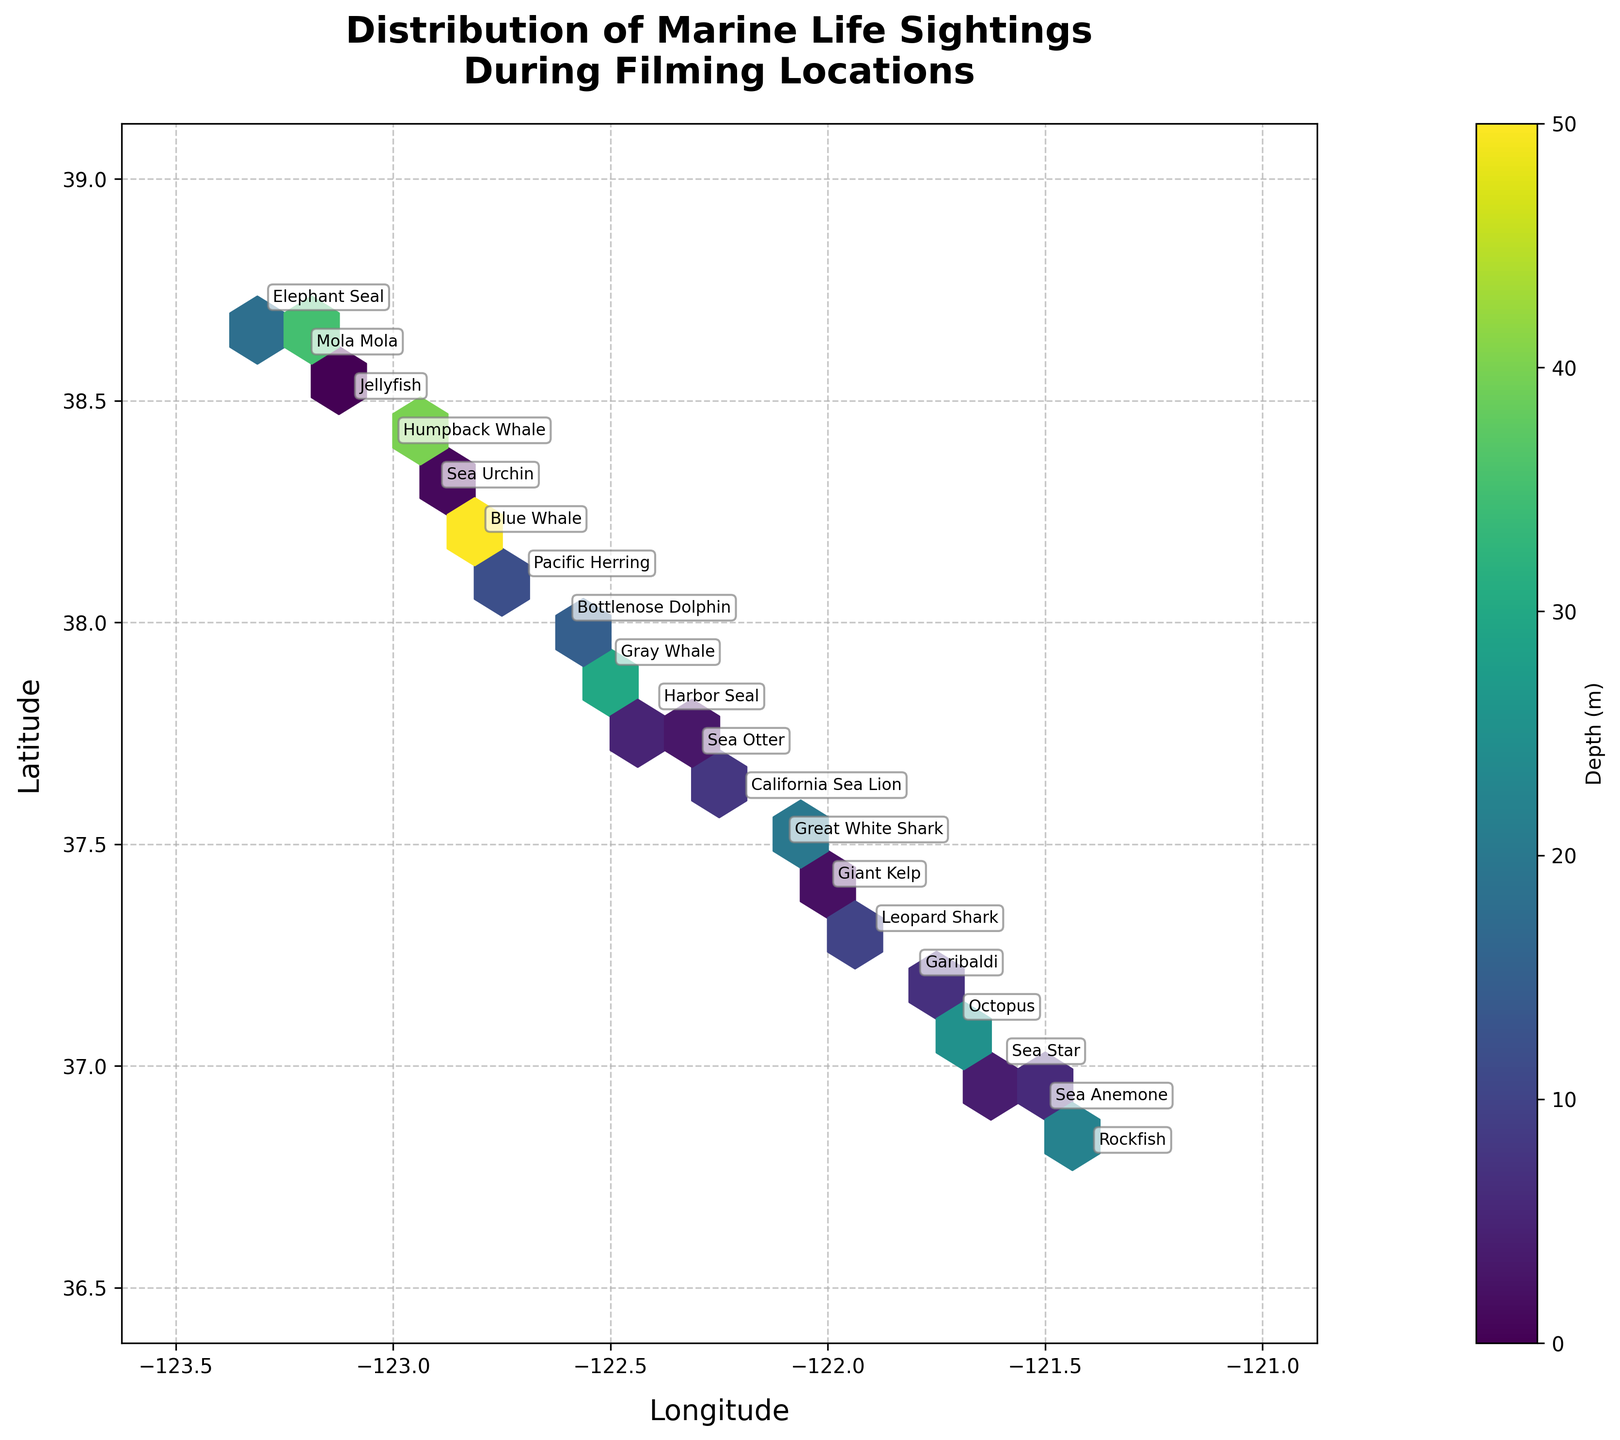What's the title of the plot? The title is displayed at the top of the plot, prominently explaining the plot's purpose. The title here is "Distribution of Marine Life Sightings During Filming Locations".
Answer: Distribution of Marine Life Sightings During Filming Locations What do the colors in the plot represent? The color bar on the right side of the plot indicates that colors represent depth in meters. Darker colors correspond to shallower depths, while lighter colors represent deeper depths.
Answer: Depth (m) What are the axes labeled? The labels for the axes are found next to each respective axis. The x-axis is labeled "Longitude" and the y-axis is labeled "Latitude".
Answer: Longitude and Latitude Which species is located at the shallowest depth? By looking at the annotations overlaid on the plot with the corresponding depths, we see that Jellyfish is marked at depth '0', which is the shallowest.
Answer: Jellyfish How does the density of sightings change from longitude -123.3 to -121.8? By observing the color density in the hexbin plot from longitude -123.3 to -121.8, we can see the density and depth of sightings reduce moving from west to east. There are more sightings near -123.3, as indicated by a higher frequency of hexagons and darker colors.
Answer: Decreases Compare the depth range for sightings of Blue Whale and Sea Urchin. Which one was seen at a greater depth? By looking at the plot annotations, Blue Whale was seen at a depth of 50 meters, while Sea Urchin was noted at a depth of 1 meter.
Answer: Blue Whale Which longitude and latitude have the most diverse species sightings? To determine species diversity, we need to look for the area with the most annotations. At longitude -122.1 and latitude 37.5, there seem to be multiple species mentioned. This indicates a higher diversity in this region.
Answer: -122.1, 37.5 Is there any overlap in sightings between Great White Shark and Garibaldi? Checking the positions of the species annotations on the plot and noting the coordinates, Great White Shark is at (-122.1, 37.5) and Garibaldi is at (-121.8, 37.2). There is no overlap as they are at different locations.
Answer: No Which species were sighted at the greatest depth? By checking the species annotations and their corresponding depths, we note that the Blue Whale was sighted at the greatest depth of 50 meters.
Answer: Blue Whale 